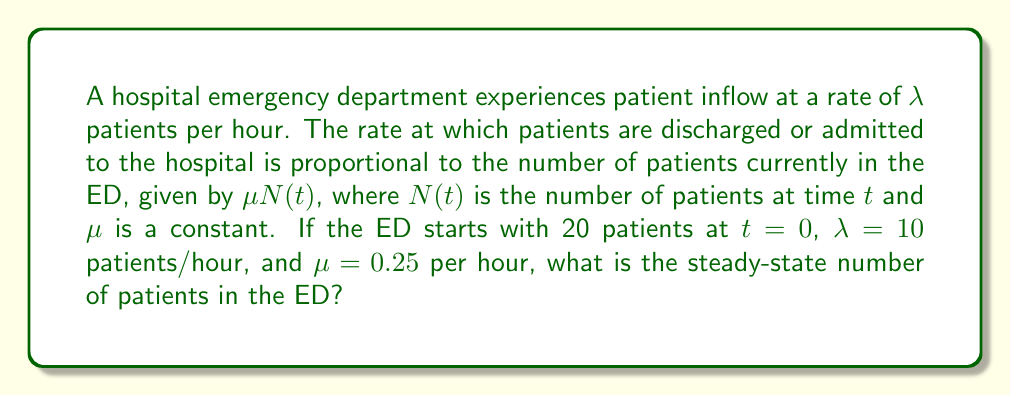Can you solve this math problem? To solve this problem, we'll use a differential equation model:

1. The rate of change of patients in the ED is given by:
   $$\frac{dN}{dt} = \lambda - \mu N(t)$$

2. At steady-state, $\frac{dN}{dt} = 0$, so:
   $$0 = \lambda - \mu N_{ss}$$
   Where $N_{ss}$ is the steady-state number of patients.

3. Rearranging the equation:
   $$\mu N_{ss} = \lambda$$
   $$N_{ss} = \frac{\lambda}{\mu}$$

4. Substituting the given values:
   $$N_{ss} = \frac{10}{0.25} = 40$$

Therefore, the steady-state number of patients in the ED is 40.
Answer: 40 patients 